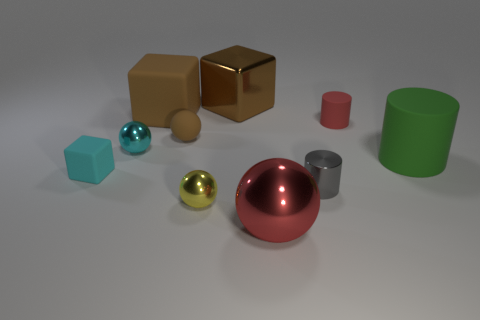Subtract all matte cylinders. How many cylinders are left? 1 Subtract all yellow balls. How many balls are left? 3 Subtract all balls. How many objects are left? 6 Subtract all green balls. Subtract all purple cylinders. How many balls are left? 4 Add 1 tiny cylinders. How many tiny cylinders exist? 3 Subtract 0 brown cylinders. How many objects are left? 10 Subtract all small objects. Subtract all tiny yellow metal objects. How many objects are left? 3 Add 9 large brown matte things. How many large brown matte things are left? 10 